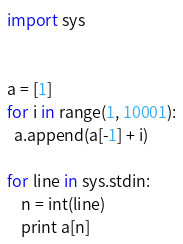<code> <loc_0><loc_0><loc_500><loc_500><_Python_>import sys


a = [1]
for i in range(1, 10001):
  a.append(a[-1] + i)

for line in sys.stdin:
    n = int(line)
    print a[n]</code> 